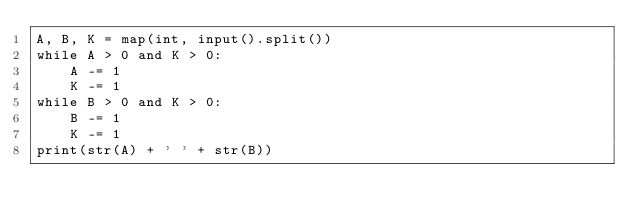Convert code to text. <code><loc_0><loc_0><loc_500><loc_500><_Python_>A, B, K = map(int, input().split())
while A > 0 and K > 0:
    A -= 1
    K -= 1
while B > 0 and K > 0:
    B -= 1
    K -= 1
print(str(A) + ' ' + str(B))</code> 